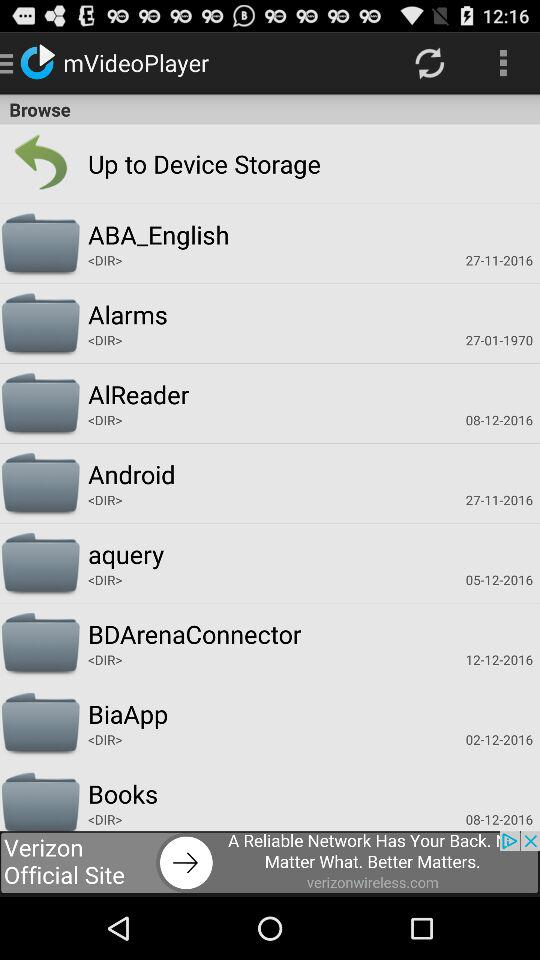What is the mentioned date for alarms? The mentioned date for alarms is January 27, 1970. 